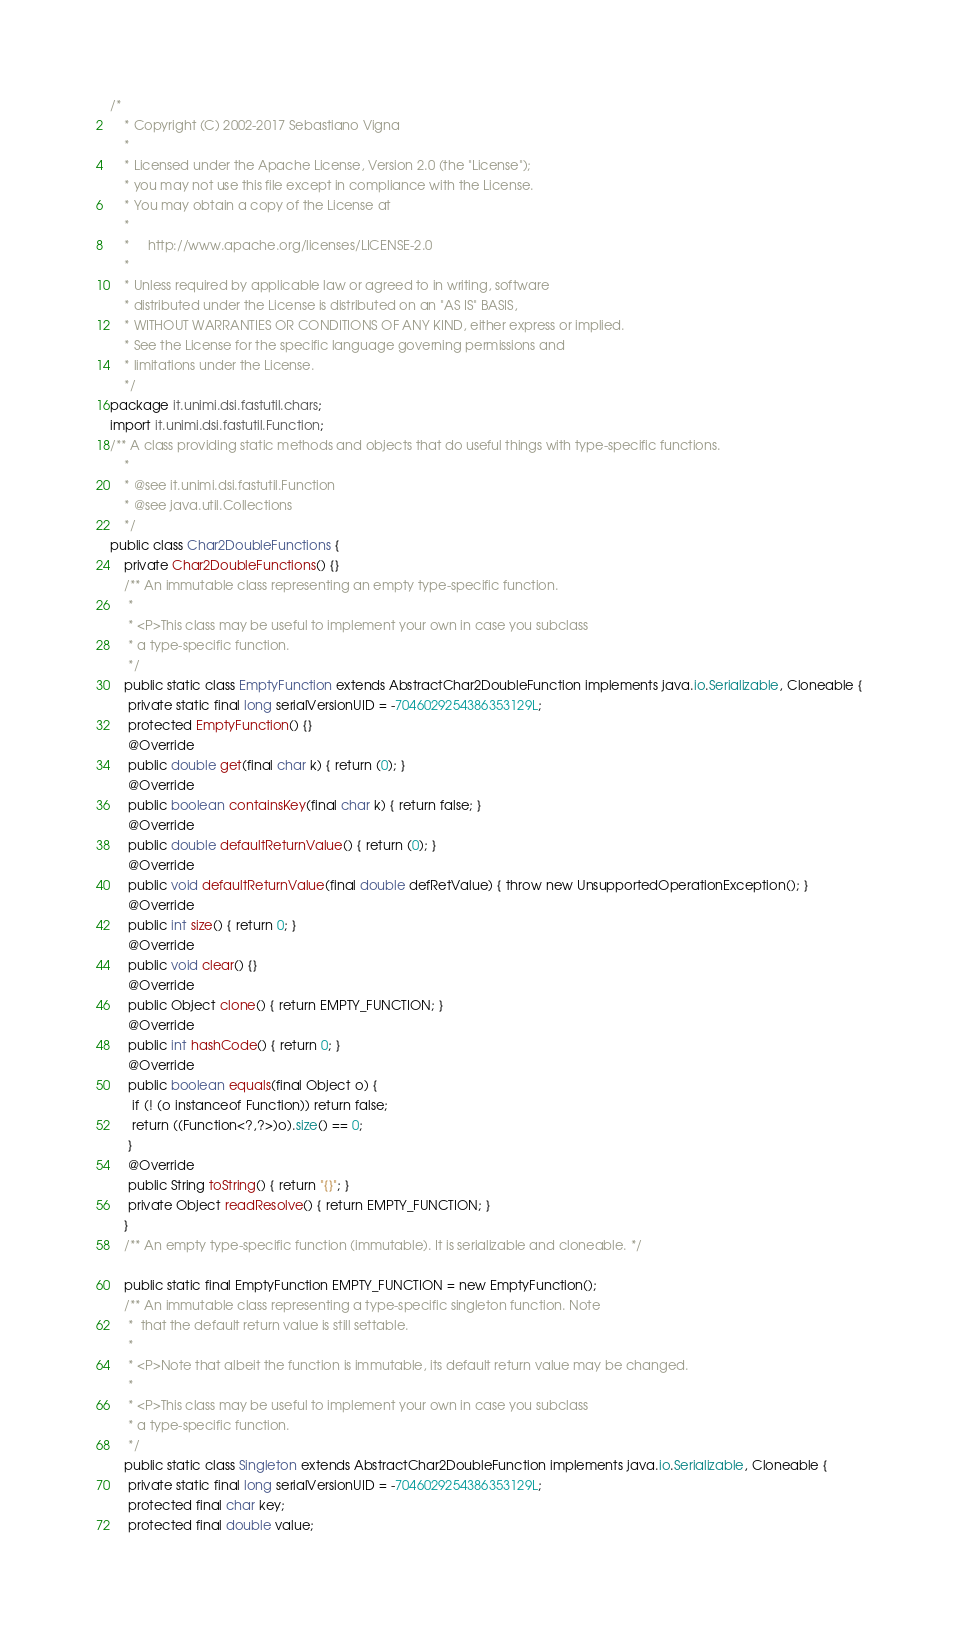Convert code to text. <code><loc_0><loc_0><loc_500><loc_500><_Java_>/*
	* Copyright (C) 2002-2017 Sebastiano Vigna
	*
	* Licensed under the Apache License, Version 2.0 (the "License");
	* you may not use this file except in compliance with the License.
	* You may obtain a copy of the License at
	*
	*     http://www.apache.org/licenses/LICENSE-2.0
	*
	* Unless required by applicable law or agreed to in writing, software
	* distributed under the License is distributed on an "AS IS" BASIS,
	* WITHOUT WARRANTIES OR CONDITIONS OF ANY KIND, either express or implied.
	* See the License for the specific language governing permissions and
	* limitations under the License.
	*/
package it.unimi.dsi.fastutil.chars;
import it.unimi.dsi.fastutil.Function;
/** A class providing static methods and objects that do useful things with type-specific functions.
	*
	* @see it.unimi.dsi.fastutil.Function
	* @see java.util.Collections
	*/
public class Char2DoubleFunctions {
	private Char2DoubleFunctions() {}
	/** An immutable class representing an empty type-specific function.
	 *
	 * <P>This class may be useful to implement your own in case you subclass
	 * a type-specific function.
	 */
	public static class EmptyFunction extends AbstractChar2DoubleFunction implements java.io.Serializable, Cloneable {
	 private static final long serialVersionUID = -7046029254386353129L;
	 protected EmptyFunction() {}
	 @Override
	 public double get(final char k) { return (0); }
	 @Override
	 public boolean containsKey(final char k) { return false; }
	 @Override
	 public double defaultReturnValue() { return (0); }
	 @Override
	 public void defaultReturnValue(final double defRetValue) { throw new UnsupportedOperationException(); }
	 @Override
	 public int size() { return 0; }
	 @Override
	 public void clear() {}
	 @Override
	 public Object clone() { return EMPTY_FUNCTION; }
	 @Override
	 public int hashCode() { return 0; }
	 @Override
	 public boolean equals(final Object o) {
	  if (! (o instanceof Function)) return false;
	  return ((Function<?,?>)o).size() == 0;
	 }
	 @Override
	 public String toString() { return "{}"; }
	 private Object readResolve() { return EMPTY_FUNCTION; }
	}
	/** An empty type-specific function (immutable). It is serializable and cloneable. */

	public static final EmptyFunction EMPTY_FUNCTION = new EmptyFunction();
	/** An immutable class representing a type-specific singleton function.	Note
	 *  that the default return value is still settable.
	 *
	 * <P>Note that albeit the function is immutable, its default return value may be changed.
	 *
	 * <P>This class may be useful to implement your own in case you subclass
	 * a type-specific function.
	 */
	public static class Singleton extends AbstractChar2DoubleFunction implements java.io.Serializable, Cloneable {
	 private static final long serialVersionUID = -7046029254386353129L;
	 protected final char key;
	 protected final double value;</code> 